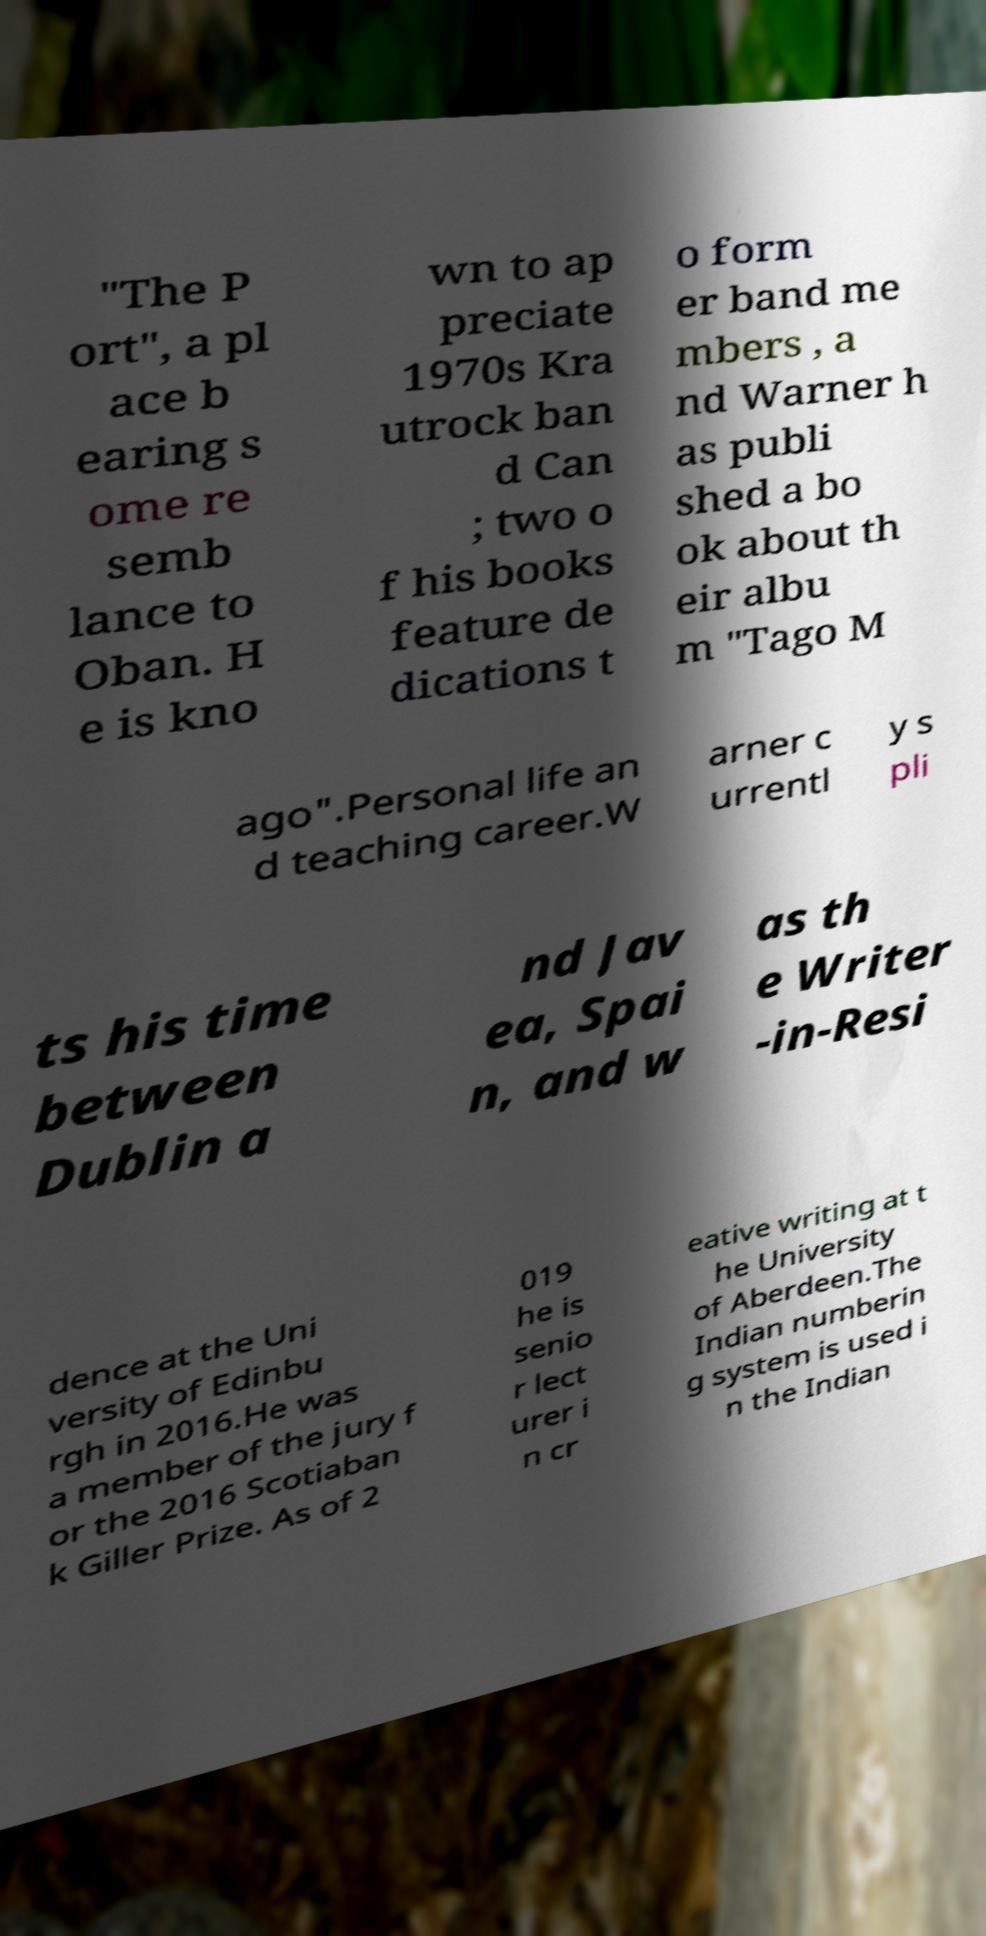There's text embedded in this image that I need extracted. Can you transcribe it verbatim? "The P ort", a pl ace b earing s ome re semb lance to Oban. H e is kno wn to ap preciate 1970s Kra utrock ban d Can ; two o f his books feature de dications t o form er band me mbers , a nd Warner h as publi shed a bo ok about th eir albu m "Tago M ago".Personal life an d teaching career.W arner c urrentl y s pli ts his time between Dublin a nd Jav ea, Spai n, and w as th e Writer -in-Resi dence at the Uni versity of Edinbu rgh in 2016.He was a member of the jury f or the 2016 Scotiaban k Giller Prize. As of 2 019 he is senio r lect urer i n cr eative writing at t he University of Aberdeen.The Indian numberin g system is used i n the Indian 